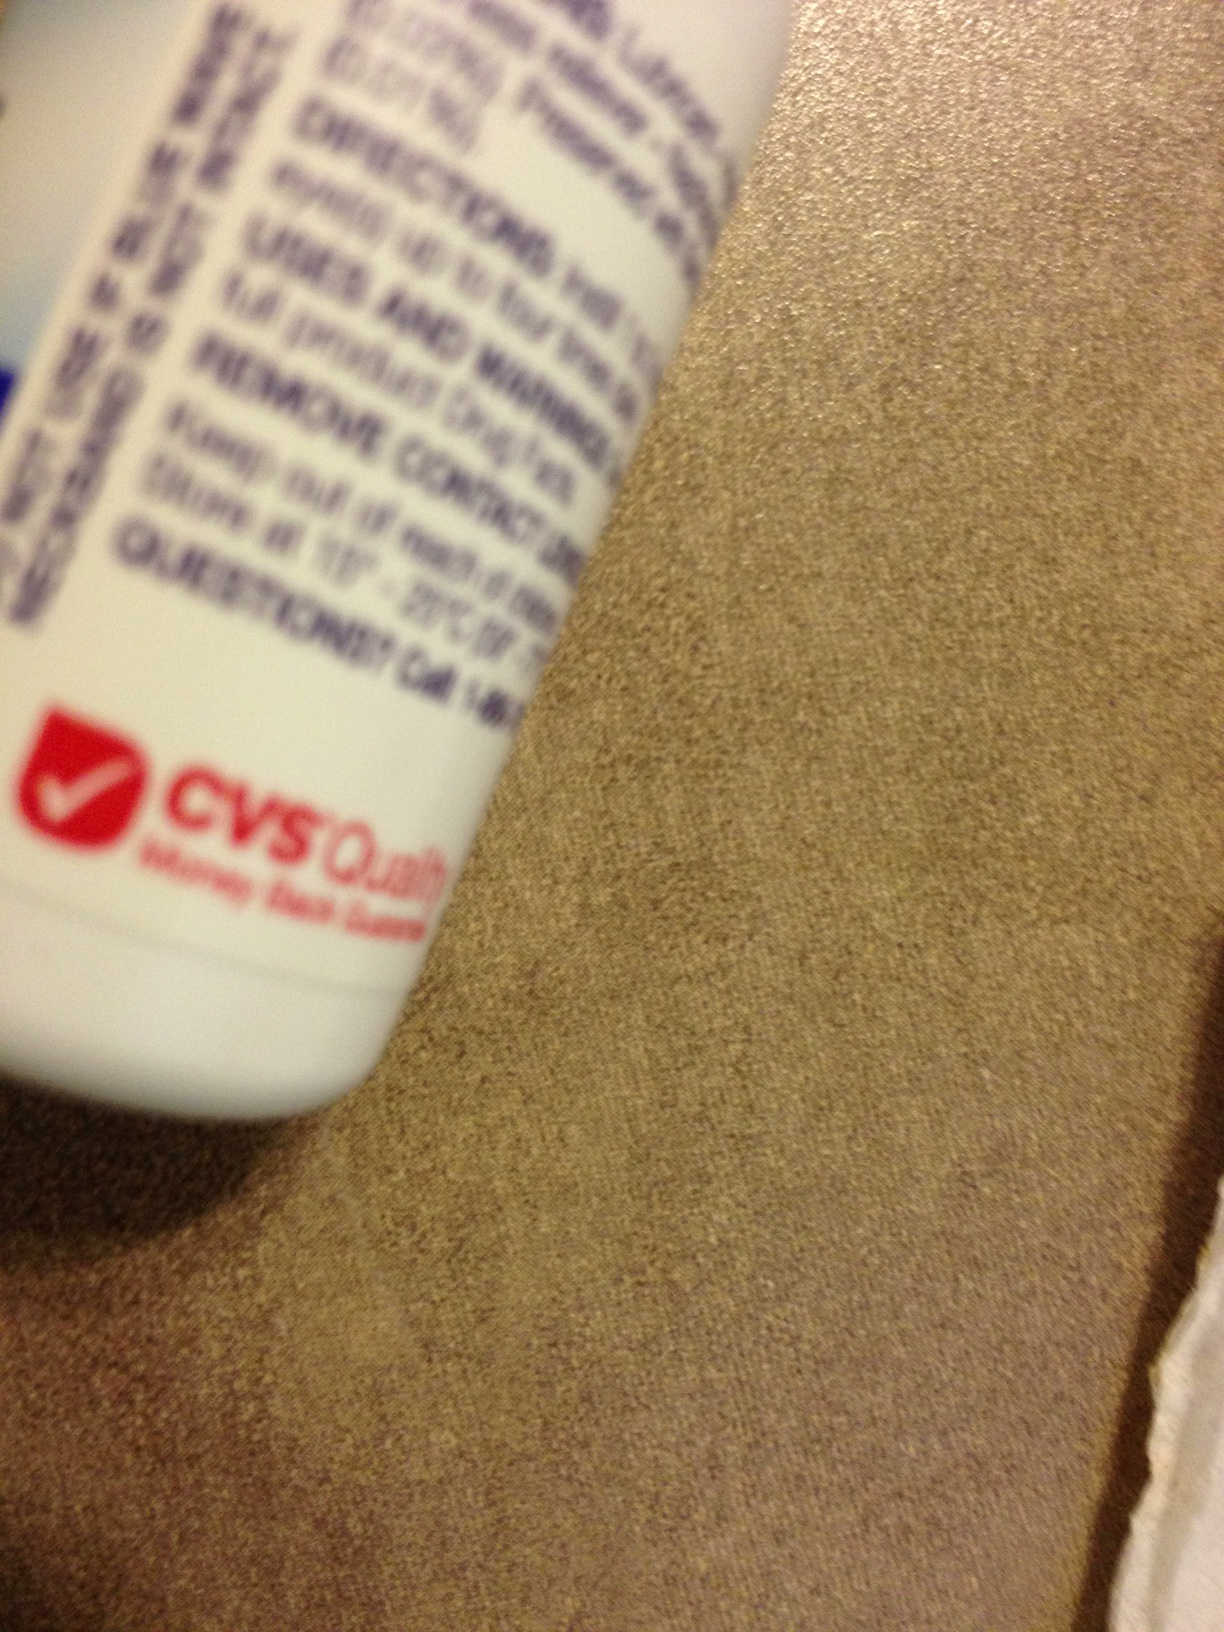What is the branding on the bottle? The visible branding on the bottle includes the CVS pharmacy logo, indicating that the product is sold at CVS pharmacies and may be part of their store-brand line of products. 